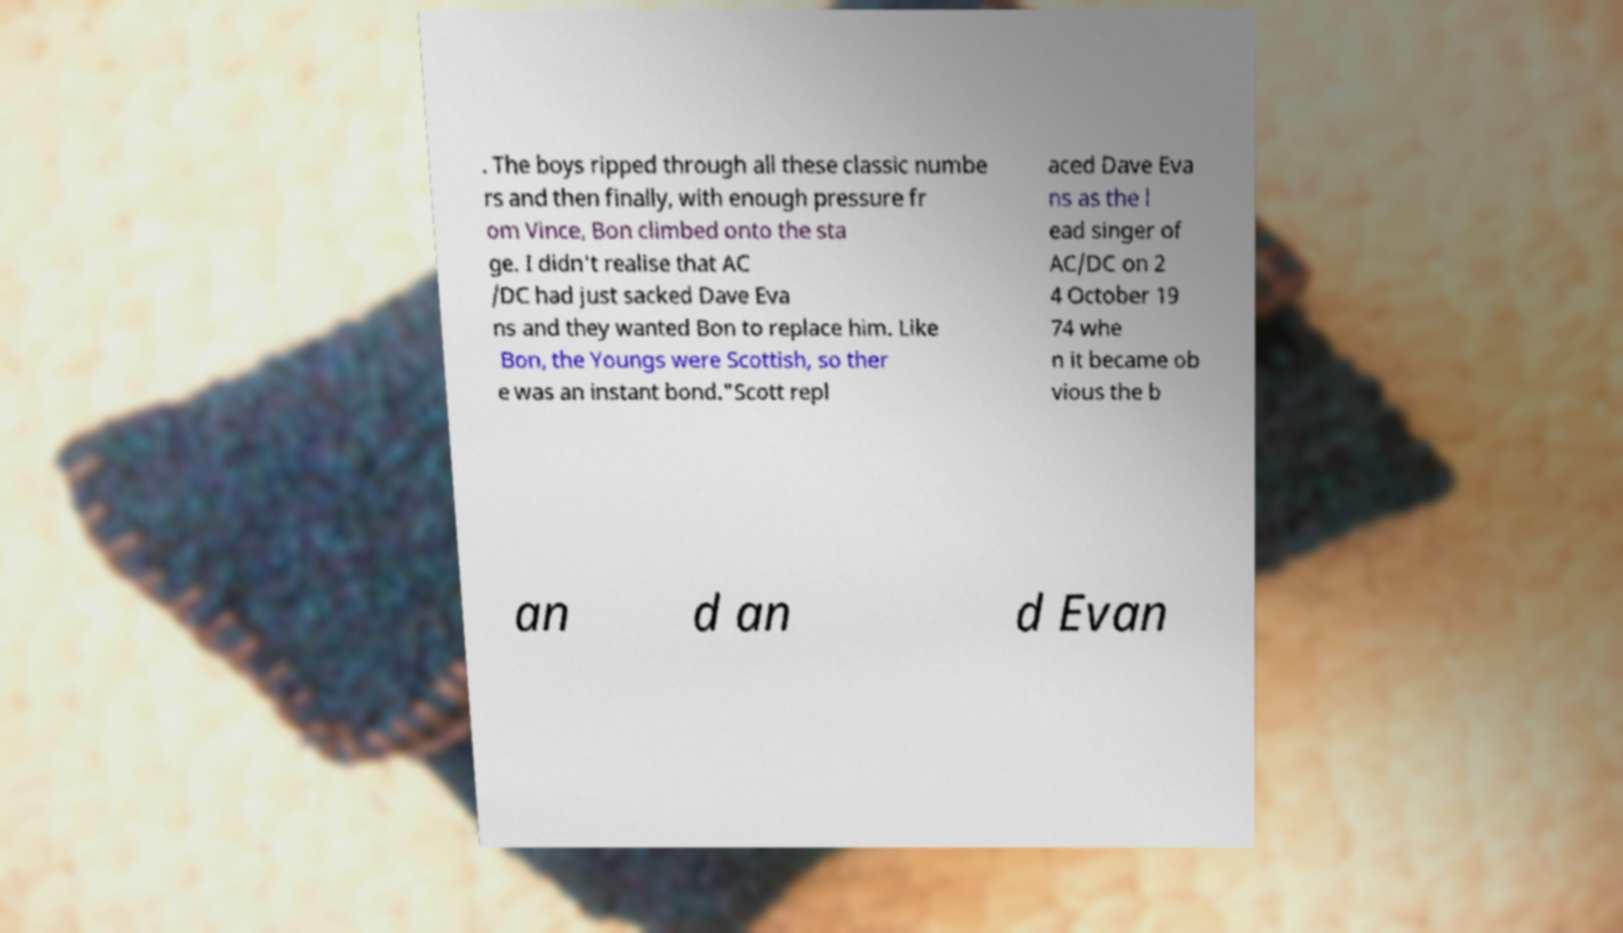Please read and relay the text visible in this image. What does it say? . The boys ripped through all these classic numbe rs and then finally, with enough pressure fr om Vince, Bon climbed onto the sta ge. I didn't realise that AC /DC had just sacked Dave Eva ns and they wanted Bon to replace him. Like Bon, the Youngs were Scottish, so ther e was an instant bond."Scott repl aced Dave Eva ns as the l ead singer of AC/DC on 2 4 October 19 74 whe n it became ob vious the b an d an d Evan 